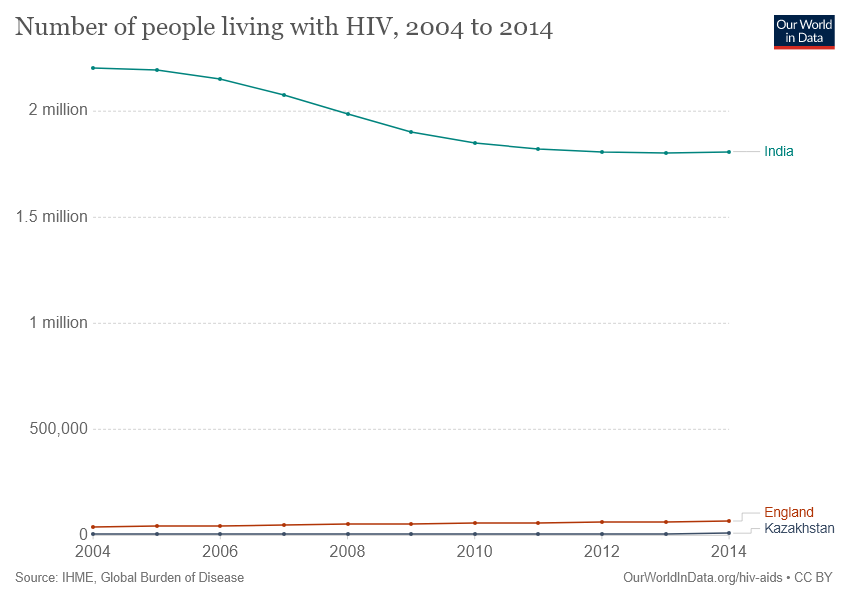Give some essential details in this illustration. The Orange line represents England, a country known for its rich history and iconic landmarks such as Big Ben and Buckingham Palace. The number of lines that have values less than 500000 is 2. 